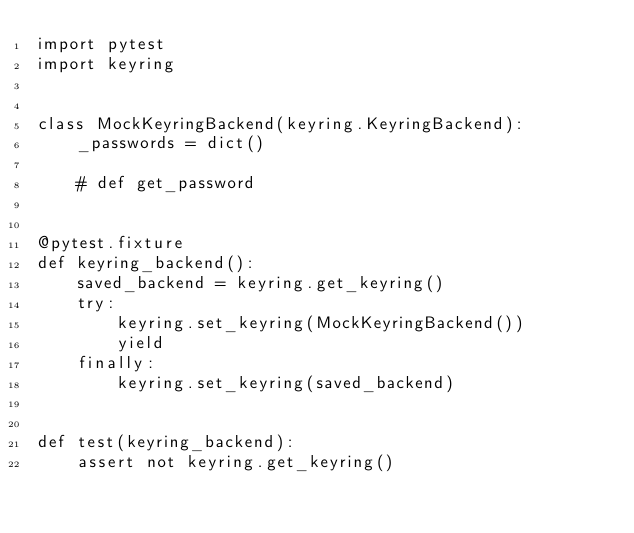<code> <loc_0><loc_0><loc_500><loc_500><_Python_>import pytest
import keyring


class MockKeyringBackend(keyring.KeyringBackend):
    _passwords = dict()

    # def get_password


@pytest.fixture
def keyring_backend():
    saved_backend = keyring.get_keyring()
    try:
        keyring.set_keyring(MockKeyringBackend())
        yield
    finally:
        keyring.set_keyring(saved_backend)


def test(keyring_backend):
    assert not keyring.get_keyring()
</code> 